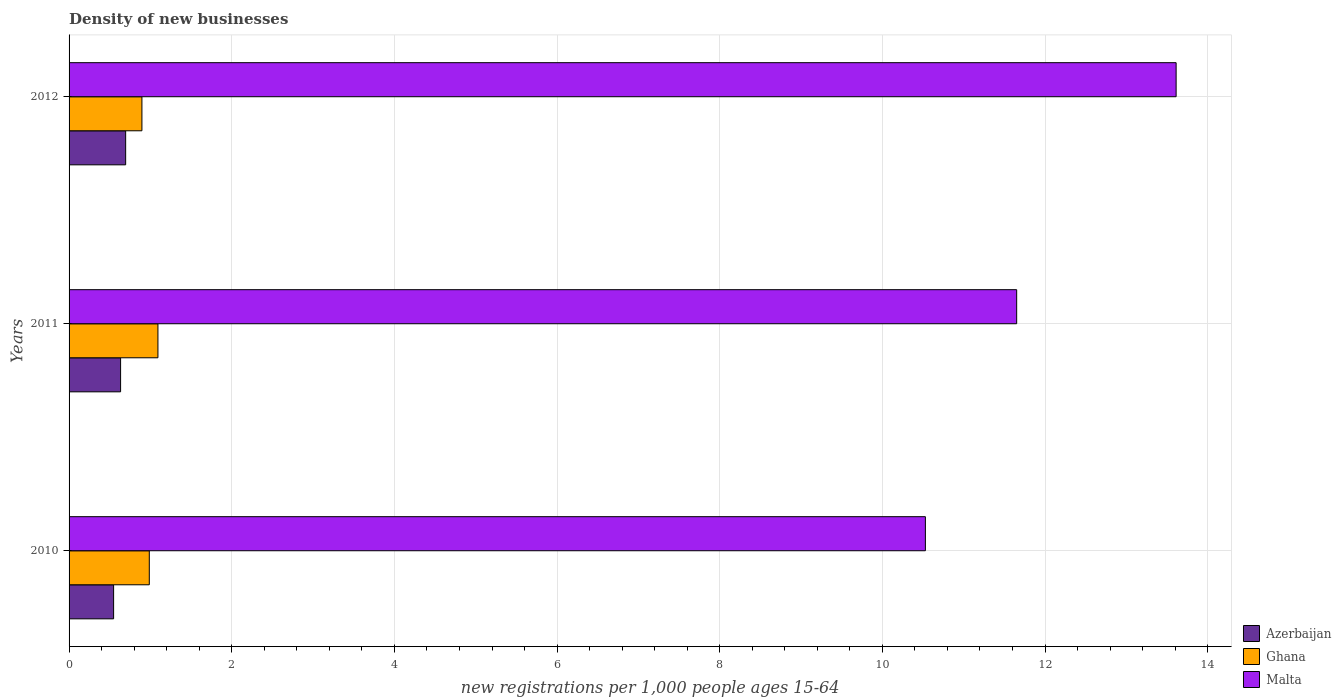Are the number of bars on each tick of the Y-axis equal?
Offer a very short reply. Yes. How many bars are there on the 2nd tick from the top?
Provide a succinct answer. 3. How many bars are there on the 1st tick from the bottom?
Offer a terse response. 3. In how many cases, is the number of bars for a given year not equal to the number of legend labels?
Your answer should be compact. 0. What is the number of new registrations in Ghana in 2010?
Provide a short and direct response. 0.99. Across all years, what is the maximum number of new registrations in Ghana?
Offer a very short reply. 1.09. Across all years, what is the minimum number of new registrations in Azerbaijan?
Offer a terse response. 0.55. In which year was the number of new registrations in Ghana maximum?
Ensure brevity in your answer.  2011. What is the total number of new registrations in Malta in the graph?
Provide a short and direct response. 35.79. What is the difference between the number of new registrations in Malta in 2010 and that in 2012?
Make the answer very short. -3.08. What is the difference between the number of new registrations in Ghana in 2011 and the number of new registrations in Azerbaijan in 2012?
Your response must be concise. 0.4. What is the average number of new registrations in Azerbaijan per year?
Your response must be concise. 0.63. In the year 2012, what is the difference between the number of new registrations in Malta and number of new registrations in Azerbaijan?
Offer a terse response. 12.92. What is the ratio of the number of new registrations in Ghana in 2011 to that in 2012?
Your response must be concise. 1.22. Is the number of new registrations in Ghana in 2011 less than that in 2012?
Provide a short and direct response. No. Is the difference between the number of new registrations in Malta in 2011 and 2012 greater than the difference between the number of new registrations in Azerbaijan in 2011 and 2012?
Your response must be concise. No. What is the difference between the highest and the second highest number of new registrations in Ghana?
Your answer should be compact. 0.11. What is the difference between the highest and the lowest number of new registrations in Malta?
Provide a succinct answer. 3.08. Is the sum of the number of new registrations in Malta in 2010 and 2011 greater than the maximum number of new registrations in Ghana across all years?
Your answer should be very brief. Yes. What does the 3rd bar from the top in 2010 represents?
Make the answer very short. Azerbaijan. What does the 3rd bar from the bottom in 2012 represents?
Your answer should be compact. Malta. Is it the case that in every year, the sum of the number of new registrations in Malta and number of new registrations in Ghana is greater than the number of new registrations in Azerbaijan?
Keep it short and to the point. Yes. How many bars are there?
Your response must be concise. 9. Are the values on the major ticks of X-axis written in scientific E-notation?
Your answer should be very brief. No. Does the graph contain any zero values?
Provide a succinct answer. No. Where does the legend appear in the graph?
Keep it short and to the point. Bottom right. How are the legend labels stacked?
Your response must be concise. Vertical. What is the title of the graph?
Offer a terse response. Density of new businesses. Does "Yemen, Rep." appear as one of the legend labels in the graph?
Offer a very short reply. No. What is the label or title of the X-axis?
Ensure brevity in your answer.  New registrations per 1,0 people ages 15-64. What is the new registrations per 1,000 people ages 15-64 in Azerbaijan in 2010?
Offer a very short reply. 0.55. What is the new registrations per 1,000 people ages 15-64 in Ghana in 2010?
Provide a succinct answer. 0.99. What is the new registrations per 1,000 people ages 15-64 of Malta in 2010?
Give a very brief answer. 10.53. What is the new registrations per 1,000 people ages 15-64 in Azerbaijan in 2011?
Ensure brevity in your answer.  0.63. What is the new registrations per 1,000 people ages 15-64 of Ghana in 2011?
Make the answer very short. 1.09. What is the new registrations per 1,000 people ages 15-64 of Malta in 2011?
Offer a terse response. 11.65. What is the new registrations per 1,000 people ages 15-64 in Azerbaijan in 2012?
Provide a succinct answer. 0.7. What is the new registrations per 1,000 people ages 15-64 of Ghana in 2012?
Provide a short and direct response. 0.9. What is the new registrations per 1,000 people ages 15-64 in Malta in 2012?
Your answer should be compact. 13.61. Across all years, what is the maximum new registrations per 1,000 people ages 15-64 of Azerbaijan?
Provide a short and direct response. 0.7. Across all years, what is the maximum new registrations per 1,000 people ages 15-64 of Ghana?
Your answer should be very brief. 1.09. Across all years, what is the maximum new registrations per 1,000 people ages 15-64 in Malta?
Your answer should be compact. 13.61. Across all years, what is the minimum new registrations per 1,000 people ages 15-64 of Azerbaijan?
Your response must be concise. 0.55. Across all years, what is the minimum new registrations per 1,000 people ages 15-64 of Ghana?
Your answer should be compact. 0.9. Across all years, what is the minimum new registrations per 1,000 people ages 15-64 of Malta?
Offer a terse response. 10.53. What is the total new registrations per 1,000 people ages 15-64 of Azerbaijan in the graph?
Provide a succinct answer. 1.88. What is the total new registrations per 1,000 people ages 15-64 of Ghana in the graph?
Your response must be concise. 2.97. What is the total new registrations per 1,000 people ages 15-64 in Malta in the graph?
Your response must be concise. 35.79. What is the difference between the new registrations per 1,000 people ages 15-64 in Azerbaijan in 2010 and that in 2011?
Keep it short and to the point. -0.09. What is the difference between the new registrations per 1,000 people ages 15-64 of Ghana in 2010 and that in 2011?
Give a very brief answer. -0.11. What is the difference between the new registrations per 1,000 people ages 15-64 of Malta in 2010 and that in 2011?
Provide a succinct answer. -1.12. What is the difference between the new registrations per 1,000 people ages 15-64 in Azerbaijan in 2010 and that in 2012?
Provide a short and direct response. -0.15. What is the difference between the new registrations per 1,000 people ages 15-64 in Ghana in 2010 and that in 2012?
Give a very brief answer. 0.09. What is the difference between the new registrations per 1,000 people ages 15-64 in Malta in 2010 and that in 2012?
Ensure brevity in your answer.  -3.08. What is the difference between the new registrations per 1,000 people ages 15-64 in Azerbaijan in 2011 and that in 2012?
Your answer should be compact. -0.06. What is the difference between the new registrations per 1,000 people ages 15-64 of Ghana in 2011 and that in 2012?
Make the answer very short. 0.2. What is the difference between the new registrations per 1,000 people ages 15-64 in Malta in 2011 and that in 2012?
Provide a short and direct response. -1.96. What is the difference between the new registrations per 1,000 people ages 15-64 in Azerbaijan in 2010 and the new registrations per 1,000 people ages 15-64 in Ghana in 2011?
Offer a terse response. -0.55. What is the difference between the new registrations per 1,000 people ages 15-64 of Azerbaijan in 2010 and the new registrations per 1,000 people ages 15-64 of Malta in 2011?
Offer a terse response. -11.1. What is the difference between the new registrations per 1,000 people ages 15-64 in Ghana in 2010 and the new registrations per 1,000 people ages 15-64 in Malta in 2011?
Provide a succinct answer. -10.66. What is the difference between the new registrations per 1,000 people ages 15-64 in Azerbaijan in 2010 and the new registrations per 1,000 people ages 15-64 in Ghana in 2012?
Keep it short and to the point. -0.35. What is the difference between the new registrations per 1,000 people ages 15-64 of Azerbaijan in 2010 and the new registrations per 1,000 people ages 15-64 of Malta in 2012?
Make the answer very short. -13.06. What is the difference between the new registrations per 1,000 people ages 15-64 of Ghana in 2010 and the new registrations per 1,000 people ages 15-64 of Malta in 2012?
Your answer should be compact. -12.63. What is the difference between the new registrations per 1,000 people ages 15-64 of Azerbaijan in 2011 and the new registrations per 1,000 people ages 15-64 of Ghana in 2012?
Give a very brief answer. -0.26. What is the difference between the new registrations per 1,000 people ages 15-64 in Azerbaijan in 2011 and the new registrations per 1,000 people ages 15-64 in Malta in 2012?
Ensure brevity in your answer.  -12.98. What is the difference between the new registrations per 1,000 people ages 15-64 of Ghana in 2011 and the new registrations per 1,000 people ages 15-64 of Malta in 2012?
Give a very brief answer. -12.52. What is the average new registrations per 1,000 people ages 15-64 of Azerbaijan per year?
Offer a very short reply. 0.63. What is the average new registrations per 1,000 people ages 15-64 of Ghana per year?
Provide a succinct answer. 0.99. What is the average new registrations per 1,000 people ages 15-64 of Malta per year?
Offer a very short reply. 11.93. In the year 2010, what is the difference between the new registrations per 1,000 people ages 15-64 in Azerbaijan and new registrations per 1,000 people ages 15-64 in Ghana?
Offer a very short reply. -0.44. In the year 2010, what is the difference between the new registrations per 1,000 people ages 15-64 in Azerbaijan and new registrations per 1,000 people ages 15-64 in Malta?
Ensure brevity in your answer.  -9.98. In the year 2010, what is the difference between the new registrations per 1,000 people ages 15-64 in Ghana and new registrations per 1,000 people ages 15-64 in Malta?
Keep it short and to the point. -9.54. In the year 2011, what is the difference between the new registrations per 1,000 people ages 15-64 in Azerbaijan and new registrations per 1,000 people ages 15-64 in Ghana?
Offer a very short reply. -0.46. In the year 2011, what is the difference between the new registrations per 1,000 people ages 15-64 in Azerbaijan and new registrations per 1,000 people ages 15-64 in Malta?
Provide a succinct answer. -11.02. In the year 2011, what is the difference between the new registrations per 1,000 people ages 15-64 in Ghana and new registrations per 1,000 people ages 15-64 in Malta?
Offer a very short reply. -10.56. In the year 2012, what is the difference between the new registrations per 1,000 people ages 15-64 of Azerbaijan and new registrations per 1,000 people ages 15-64 of Ghana?
Your answer should be very brief. -0.2. In the year 2012, what is the difference between the new registrations per 1,000 people ages 15-64 of Azerbaijan and new registrations per 1,000 people ages 15-64 of Malta?
Make the answer very short. -12.92. In the year 2012, what is the difference between the new registrations per 1,000 people ages 15-64 of Ghana and new registrations per 1,000 people ages 15-64 of Malta?
Give a very brief answer. -12.72. What is the ratio of the new registrations per 1,000 people ages 15-64 of Azerbaijan in 2010 to that in 2011?
Offer a very short reply. 0.86. What is the ratio of the new registrations per 1,000 people ages 15-64 of Ghana in 2010 to that in 2011?
Ensure brevity in your answer.  0.9. What is the ratio of the new registrations per 1,000 people ages 15-64 of Malta in 2010 to that in 2011?
Provide a succinct answer. 0.9. What is the ratio of the new registrations per 1,000 people ages 15-64 in Azerbaijan in 2010 to that in 2012?
Provide a succinct answer. 0.79. What is the ratio of the new registrations per 1,000 people ages 15-64 of Ghana in 2010 to that in 2012?
Offer a terse response. 1.1. What is the ratio of the new registrations per 1,000 people ages 15-64 in Malta in 2010 to that in 2012?
Keep it short and to the point. 0.77. What is the ratio of the new registrations per 1,000 people ages 15-64 in Azerbaijan in 2011 to that in 2012?
Your response must be concise. 0.91. What is the ratio of the new registrations per 1,000 people ages 15-64 of Ghana in 2011 to that in 2012?
Give a very brief answer. 1.22. What is the ratio of the new registrations per 1,000 people ages 15-64 of Malta in 2011 to that in 2012?
Ensure brevity in your answer.  0.86. What is the difference between the highest and the second highest new registrations per 1,000 people ages 15-64 of Azerbaijan?
Provide a short and direct response. 0.06. What is the difference between the highest and the second highest new registrations per 1,000 people ages 15-64 in Ghana?
Provide a succinct answer. 0.11. What is the difference between the highest and the second highest new registrations per 1,000 people ages 15-64 in Malta?
Give a very brief answer. 1.96. What is the difference between the highest and the lowest new registrations per 1,000 people ages 15-64 in Azerbaijan?
Make the answer very short. 0.15. What is the difference between the highest and the lowest new registrations per 1,000 people ages 15-64 in Ghana?
Offer a terse response. 0.2. What is the difference between the highest and the lowest new registrations per 1,000 people ages 15-64 in Malta?
Your response must be concise. 3.08. 